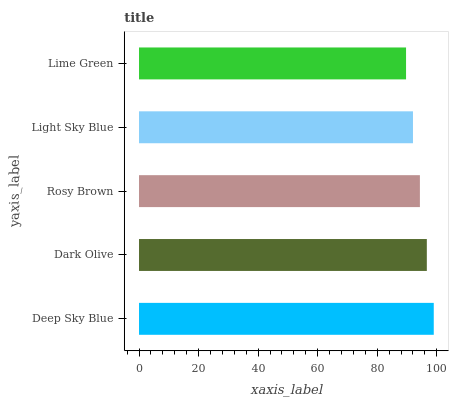Is Lime Green the minimum?
Answer yes or no. Yes. Is Deep Sky Blue the maximum?
Answer yes or no. Yes. Is Dark Olive the minimum?
Answer yes or no. No. Is Dark Olive the maximum?
Answer yes or no. No. Is Deep Sky Blue greater than Dark Olive?
Answer yes or no. Yes. Is Dark Olive less than Deep Sky Blue?
Answer yes or no. Yes. Is Dark Olive greater than Deep Sky Blue?
Answer yes or no. No. Is Deep Sky Blue less than Dark Olive?
Answer yes or no. No. Is Rosy Brown the high median?
Answer yes or no. Yes. Is Rosy Brown the low median?
Answer yes or no. Yes. Is Deep Sky Blue the high median?
Answer yes or no. No. Is Light Sky Blue the low median?
Answer yes or no. No. 